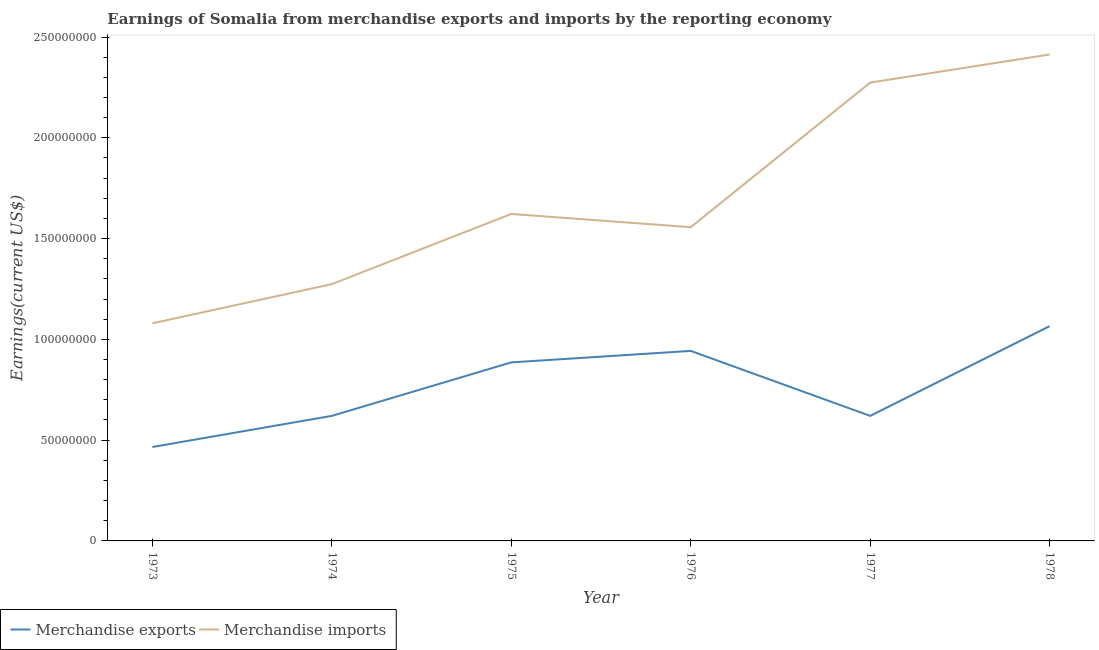How many different coloured lines are there?
Keep it short and to the point. 2. What is the earnings from merchandise exports in 1975?
Provide a succinct answer. 8.86e+07. Across all years, what is the maximum earnings from merchandise exports?
Ensure brevity in your answer.  1.07e+08. Across all years, what is the minimum earnings from merchandise exports?
Ensure brevity in your answer.  4.66e+07. In which year was the earnings from merchandise imports maximum?
Keep it short and to the point. 1978. In which year was the earnings from merchandise exports minimum?
Provide a succinct answer. 1973. What is the total earnings from merchandise imports in the graph?
Offer a terse response. 1.02e+09. What is the difference between the earnings from merchandise imports in 1974 and that in 1976?
Make the answer very short. -2.83e+07. What is the difference between the earnings from merchandise exports in 1976 and the earnings from merchandise imports in 1977?
Your answer should be very brief. -1.33e+08. What is the average earnings from merchandise exports per year?
Your answer should be very brief. 7.67e+07. In the year 1974, what is the difference between the earnings from merchandise exports and earnings from merchandise imports?
Offer a terse response. -6.54e+07. In how many years, is the earnings from merchandise imports greater than 190000000 US$?
Your answer should be compact. 2. What is the ratio of the earnings from merchandise imports in 1973 to that in 1974?
Your answer should be very brief. 0.85. What is the difference between the highest and the second highest earnings from merchandise exports?
Offer a very short reply. 1.23e+07. What is the difference between the highest and the lowest earnings from merchandise imports?
Ensure brevity in your answer.  1.33e+08. Is the earnings from merchandise imports strictly greater than the earnings from merchandise exports over the years?
Provide a succinct answer. Yes. Is the earnings from merchandise exports strictly less than the earnings from merchandise imports over the years?
Make the answer very short. Yes. How many years are there in the graph?
Ensure brevity in your answer.  6. Does the graph contain any zero values?
Give a very brief answer. No. Does the graph contain grids?
Ensure brevity in your answer.  No. Where does the legend appear in the graph?
Ensure brevity in your answer.  Bottom left. How many legend labels are there?
Provide a succinct answer. 2. What is the title of the graph?
Offer a very short reply. Earnings of Somalia from merchandise exports and imports by the reporting economy. Does "Female labourers" appear as one of the legend labels in the graph?
Offer a very short reply. No. What is the label or title of the Y-axis?
Your answer should be compact. Earnings(current US$). What is the Earnings(current US$) of Merchandise exports in 1973?
Provide a short and direct response. 4.66e+07. What is the Earnings(current US$) of Merchandise imports in 1973?
Keep it short and to the point. 1.08e+08. What is the Earnings(current US$) in Merchandise exports in 1974?
Give a very brief answer. 6.20e+07. What is the Earnings(current US$) of Merchandise imports in 1974?
Provide a short and direct response. 1.27e+08. What is the Earnings(current US$) of Merchandise exports in 1975?
Your answer should be compact. 8.86e+07. What is the Earnings(current US$) of Merchandise imports in 1975?
Ensure brevity in your answer.  1.62e+08. What is the Earnings(current US$) in Merchandise exports in 1976?
Make the answer very short. 9.43e+07. What is the Earnings(current US$) in Merchandise imports in 1976?
Ensure brevity in your answer.  1.56e+08. What is the Earnings(current US$) of Merchandise exports in 1977?
Provide a succinct answer. 6.20e+07. What is the Earnings(current US$) in Merchandise imports in 1977?
Give a very brief answer. 2.27e+08. What is the Earnings(current US$) in Merchandise exports in 1978?
Offer a very short reply. 1.07e+08. What is the Earnings(current US$) in Merchandise imports in 1978?
Your answer should be very brief. 2.41e+08. Across all years, what is the maximum Earnings(current US$) of Merchandise exports?
Ensure brevity in your answer.  1.07e+08. Across all years, what is the maximum Earnings(current US$) in Merchandise imports?
Your answer should be very brief. 2.41e+08. Across all years, what is the minimum Earnings(current US$) of Merchandise exports?
Your answer should be compact. 4.66e+07. Across all years, what is the minimum Earnings(current US$) in Merchandise imports?
Keep it short and to the point. 1.08e+08. What is the total Earnings(current US$) in Merchandise exports in the graph?
Provide a short and direct response. 4.60e+08. What is the total Earnings(current US$) in Merchandise imports in the graph?
Your response must be concise. 1.02e+09. What is the difference between the Earnings(current US$) of Merchandise exports in 1973 and that in 1974?
Give a very brief answer. -1.54e+07. What is the difference between the Earnings(current US$) in Merchandise imports in 1973 and that in 1974?
Your answer should be very brief. -1.95e+07. What is the difference between the Earnings(current US$) in Merchandise exports in 1973 and that in 1975?
Provide a short and direct response. -4.20e+07. What is the difference between the Earnings(current US$) in Merchandise imports in 1973 and that in 1975?
Offer a very short reply. -5.43e+07. What is the difference between the Earnings(current US$) of Merchandise exports in 1973 and that in 1976?
Provide a short and direct response. -4.77e+07. What is the difference between the Earnings(current US$) of Merchandise imports in 1973 and that in 1976?
Make the answer very short. -4.77e+07. What is the difference between the Earnings(current US$) of Merchandise exports in 1973 and that in 1977?
Ensure brevity in your answer.  -1.54e+07. What is the difference between the Earnings(current US$) of Merchandise imports in 1973 and that in 1977?
Ensure brevity in your answer.  -1.19e+08. What is the difference between the Earnings(current US$) in Merchandise exports in 1973 and that in 1978?
Provide a short and direct response. -6.00e+07. What is the difference between the Earnings(current US$) in Merchandise imports in 1973 and that in 1978?
Provide a short and direct response. -1.33e+08. What is the difference between the Earnings(current US$) in Merchandise exports in 1974 and that in 1975?
Provide a short and direct response. -2.65e+07. What is the difference between the Earnings(current US$) in Merchandise imports in 1974 and that in 1975?
Provide a succinct answer. -3.48e+07. What is the difference between the Earnings(current US$) of Merchandise exports in 1974 and that in 1976?
Your response must be concise. -3.22e+07. What is the difference between the Earnings(current US$) in Merchandise imports in 1974 and that in 1976?
Provide a short and direct response. -2.83e+07. What is the difference between the Earnings(current US$) in Merchandise exports in 1974 and that in 1977?
Your answer should be compact. 7000. What is the difference between the Earnings(current US$) of Merchandise imports in 1974 and that in 1977?
Give a very brief answer. -1.00e+08. What is the difference between the Earnings(current US$) in Merchandise exports in 1974 and that in 1978?
Your response must be concise. -4.45e+07. What is the difference between the Earnings(current US$) in Merchandise imports in 1974 and that in 1978?
Give a very brief answer. -1.14e+08. What is the difference between the Earnings(current US$) in Merchandise exports in 1975 and that in 1976?
Your response must be concise. -5.70e+06. What is the difference between the Earnings(current US$) in Merchandise imports in 1975 and that in 1976?
Make the answer very short. 6.56e+06. What is the difference between the Earnings(current US$) in Merchandise exports in 1975 and that in 1977?
Offer a very short reply. 2.65e+07. What is the difference between the Earnings(current US$) in Merchandise imports in 1975 and that in 1977?
Make the answer very short. -6.52e+07. What is the difference between the Earnings(current US$) in Merchandise exports in 1975 and that in 1978?
Your response must be concise. -1.80e+07. What is the difference between the Earnings(current US$) of Merchandise imports in 1975 and that in 1978?
Keep it short and to the point. -7.91e+07. What is the difference between the Earnings(current US$) in Merchandise exports in 1976 and that in 1977?
Your answer should be very brief. 3.22e+07. What is the difference between the Earnings(current US$) of Merchandise imports in 1976 and that in 1977?
Offer a terse response. -7.17e+07. What is the difference between the Earnings(current US$) in Merchandise exports in 1976 and that in 1978?
Keep it short and to the point. -1.23e+07. What is the difference between the Earnings(current US$) of Merchandise imports in 1976 and that in 1978?
Give a very brief answer. -8.57e+07. What is the difference between the Earnings(current US$) of Merchandise exports in 1977 and that in 1978?
Offer a terse response. -4.45e+07. What is the difference between the Earnings(current US$) in Merchandise imports in 1977 and that in 1978?
Provide a succinct answer. -1.39e+07. What is the difference between the Earnings(current US$) in Merchandise exports in 1973 and the Earnings(current US$) in Merchandise imports in 1974?
Keep it short and to the point. -8.08e+07. What is the difference between the Earnings(current US$) in Merchandise exports in 1973 and the Earnings(current US$) in Merchandise imports in 1975?
Provide a short and direct response. -1.16e+08. What is the difference between the Earnings(current US$) in Merchandise exports in 1973 and the Earnings(current US$) in Merchandise imports in 1976?
Provide a short and direct response. -1.09e+08. What is the difference between the Earnings(current US$) in Merchandise exports in 1973 and the Earnings(current US$) in Merchandise imports in 1977?
Provide a short and direct response. -1.81e+08. What is the difference between the Earnings(current US$) in Merchandise exports in 1973 and the Earnings(current US$) in Merchandise imports in 1978?
Provide a short and direct response. -1.95e+08. What is the difference between the Earnings(current US$) of Merchandise exports in 1974 and the Earnings(current US$) of Merchandise imports in 1975?
Your answer should be compact. -1.00e+08. What is the difference between the Earnings(current US$) in Merchandise exports in 1974 and the Earnings(current US$) in Merchandise imports in 1976?
Make the answer very short. -9.36e+07. What is the difference between the Earnings(current US$) of Merchandise exports in 1974 and the Earnings(current US$) of Merchandise imports in 1977?
Make the answer very short. -1.65e+08. What is the difference between the Earnings(current US$) in Merchandise exports in 1974 and the Earnings(current US$) in Merchandise imports in 1978?
Offer a terse response. -1.79e+08. What is the difference between the Earnings(current US$) in Merchandise exports in 1975 and the Earnings(current US$) in Merchandise imports in 1976?
Offer a very short reply. -6.71e+07. What is the difference between the Earnings(current US$) of Merchandise exports in 1975 and the Earnings(current US$) of Merchandise imports in 1977?
Your answer should be very brief. -1.39e+08. What is the difference between the Earnings(current US$) in Merchandise exports in 1975 and the Earnings(current US$) in Merchandise imports in 1978?
Keep it short and to the point. -1.53e+08. What is the difference between the Earnings(current US$) of Merchandise exports in 1976 and the Earnings(current US$) of Merchandise imports in 1977?
Provide a succinct answer. -1.33e+08. What is the difference between the Earnings(current US$) of Merchandise exports in 1976 and the Earnings(current US$) of Merchandise imports in 1978?
Provide a succinct answer. -1.47e+08. What is the difference between the Earnings(current US$) in Merchandise exports in 1977 and the Earnings(current US$) in Merchandise imports in 1978?
Your response must be concise. -1.79e+08. What is the average Earnings(current US$) in Merchandise exports per year?
Make the answer very short. 7.67e+07. What is the average Earnings(current US$) of Merchandise imports per year?
Your answer should be very brief. 1.70e+08. In the year 1973, what is the difference between the Earnings(current US$) of Merchandise exports and Earnings(current US$) of Merchandise imports?
Offer a terse response. -6.14e+07. In the year 1974, what is the difference between the Earnings(current US$) in Merchandise exports and Earnings(current US$) in Merchandise imports?
Give a very brief answer. -6.54e+07. In the year 1975, what is the difference between the Earnings(current US$) in Merchandise exports and Earnings(current US$) in Merchandise imports?
Your answer should be very brief. -7.36e+07. In the year 1976, what is the difference between the Earnings(current US$) of Merchandise exports and Earnings(current US$) of Merchandise imports?
Offer a terse response. -6.14e+07. In the year 1977, what is the difference between the Earnings(current US$) of Merchandise exports and Earnings(current US$) of Merchandise imports?
Your answer should be very brief. -1.65e+08. In the year 1978, what is the difference between the Earnings(current US$) in Merchandise exports and Earnings(current US$) in Merchandise imports?
Your answer should be compact. -1.35e+08. What is the ratio of the Earnings(current US$) of Merchandise exports in 1973 to that in 1974?
Give a very brief answer. 0.75. What is the ratio of the Earnings(current US$) of Merchandise imports in 1973 to that in 1974?
Your answer should be compact. 0.85. What is the ratio of the Earnings(current US$) of Merchandise exports in 1973 to that in 1975?
Make the answer very short. 0.53. What is the ratio of the Earnings(current US$) in Merchandise imports in 1973 to that in 1975?
Provide a short and direct response. 0.67. What is the ratio of the Earnings(current US$) of Merchandise exports in 1973 to that in 1976?
Offer a terse response. 0.49. What is the ratio of the Earnings(current US$) in Merchandise imports in 1973 to that in 1976?
Keep it short and to the point. 0.69. What is the ratio of the Earnings(current US$) of Merchandise exports in 1973 to that in 1977?
Make the answer very short. 0.75. What is the ratio of the Earnings(current US$) in Merchandise imports in 1973 to that in 1977?
Provide a succinct answer. 0.47. What is the ratio of the Earnings(current US$) of Merchandise exports in 1973 to that in 1978?
Provide a succinct answer. 0.44. What is the ratio of the Earnings(current US$) in Merchandise imports in 1973 to that in 1978?
Ensure brevity in your answer.  0.45. What is the ratio of the Earnings(current US$) of Merchandise exports in 1974 to that in 1975?
Make the answer very short. 0.7. What is the ratio of the Earnings(current US$) in Merchandise imports in 1974 to that in 1975?
Make the answer very short. 0.79. What is the ratio of the Earnings(current US$) of Merchandise exports in 1974 to that in 1976?
Give a very brief answer. 0.66. What is the ratio of the Earnings(current US$) in Merchandise imports in 1974 to that in 1976?
Give a very brief answer. 0.82. What is the ratio of the Earnings(current US$) in Merchandise exports in 1974 to that in 1977?
Offer a terse response. 1. What is the ratio of the Earnings(current US$) of Merchandise imports in 1974 to that in 1977?
Offer a terse response. 0.56. What is the ratio of the Earnings(current US$) of Merchandise exports in 1974 to that in 1978?
Offer a very short reply. 0.58. What is the ratio of the Earnings(current US$) in Merchandise imports in 1974 to that in 1978?
Your response must be concise. 0.53. What is the ratio of the Earnings(current US$) in Merchandise exports in 1975 to that in 1976?
Provide a short and direct response. 0.94. What is the ratio of the Earnings(current US$) of Merchandise imports in 1975 to that in 1976?
Give a very brief answer. 1.04. What is the ratio of the Earnings(current US$) of Merchandise exports in 1975 to that in 1977?
Offer a very short reply. 1.43. What is the ratio of the Earnings(current US$) in Merchandise imports in 1975 to that in 1977?
Offer a terse response. 0.71. What is the ratio of the Earnings(current US$) in Merchandise exports in 1975 to that in 1978?
Your answer should be very brief. 0.83. What is the ratio of the Earnings(current US$) in Merchandise imports in 1975 to that in 1978?
Offer a very short reply. 0.67. What is the ratio of the Earnings(current US$) of Merchandise exports in 1976 to that in 1977?
Keep it short and to the point. 1.52. What is the ratio of the Earnings(current US$) in Merchandise imports in 1976 to that in 1977?
Keep it short and to the point. 0.68. What is the ratio of the Earnings(current US$) in Merchandise exports in 1976 to that in 1978?
Make the answer very short. 0.88. What is the ratio of the Earnings(current US$) of Merchandise imports in 1976 to that in 1978?
Your answer should be compact. 0.65. What is the ratio of the Earnings(current US$) in Merchandise exports in 1977 to that in 1978?
Your response must be concise. 0.58. What is the ratio of the Earnings(current US$) in Merchandise imports in 1977 to that in 1978?
Your answer should be very brief. 0.94. What is the difference between the highest and the second highest Earnings(current US$) in Merchandise exports?
Provide a short and direct response. 1.23e+07. What is the difference between the highest and the second highest Earnings(current US$) of Merchandise imports?
Your answer should be compact. 1.39e+07. What is the difference between the highest and the lowest Earnings(current US$) in Merchandise exports?
Give a very brief answer. 6.00e+07. What is the difference between the highest and the lowest Earnings(current US$) of Merchandise imports?
Offer a terse response. 1.33e+08. 